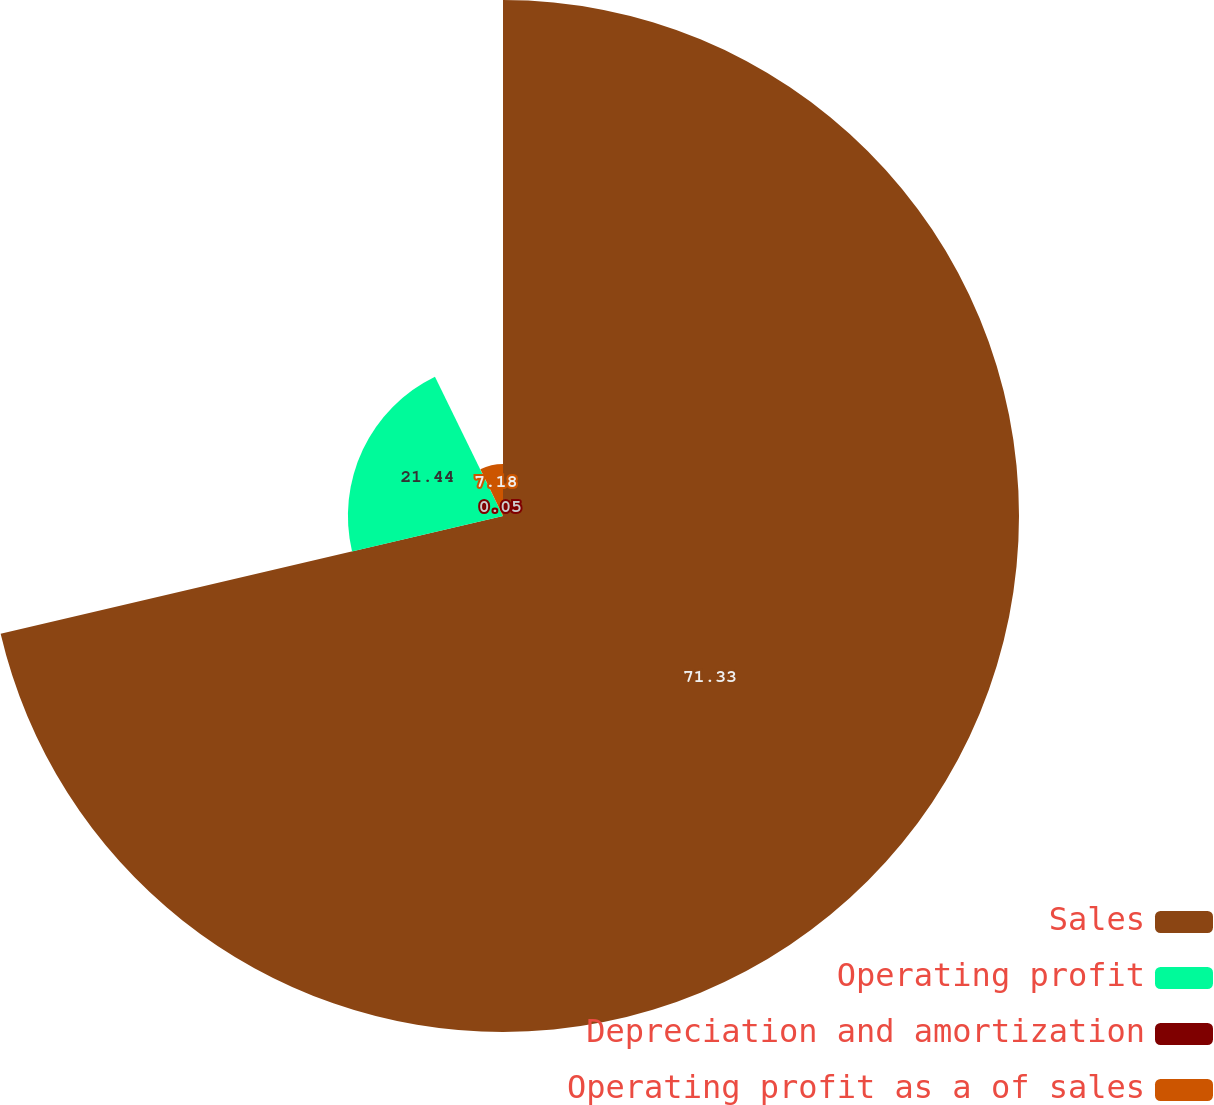<chart> <loc_0><loc_0><loc_500><loc_500><pie_chart><fcel>Sales<fcel>Operating profit<fcel>Depreciation and amortization<fcel>Operating profit as a of sales<nl><fcel>71.34%<fcel>21.44%<fcel>0.05%<fcel>7.18%<nl></chart> 